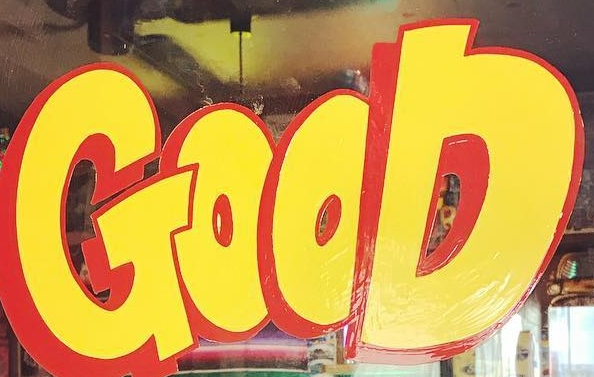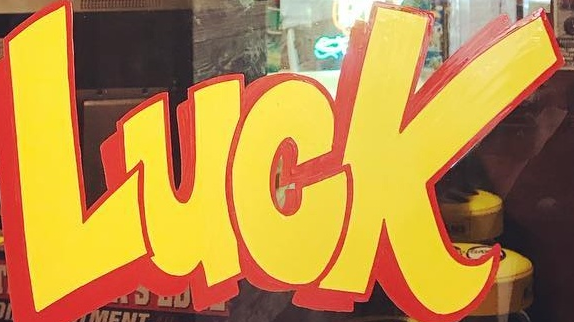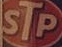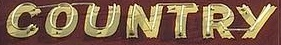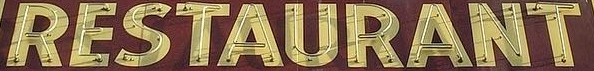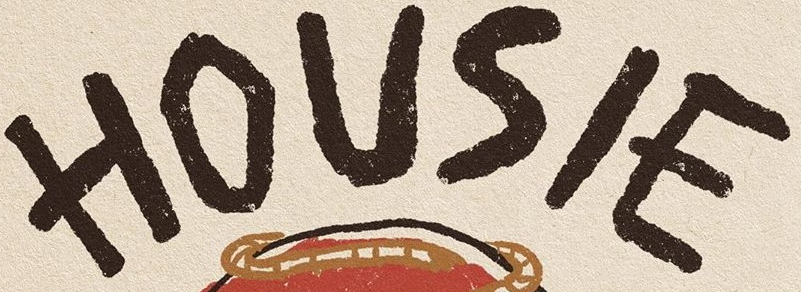Transcribe the words shown in these images in order, separated by a semicolon. GOOD; LUCK; STP; COUNTRY; RESTAURANT; HOUSIE 